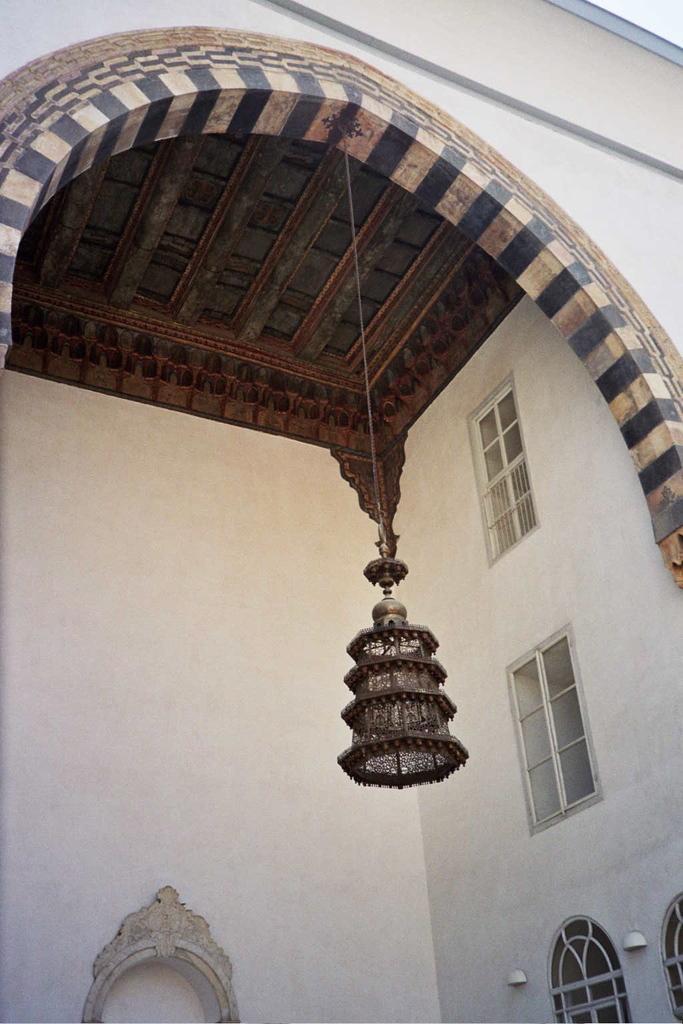In one or two sentences, can you explain what this image depicts? In this image there is a lamp hanging from the roof of a building. There are few windows to the wall. Right bottom there are few lights attached to the wall. 